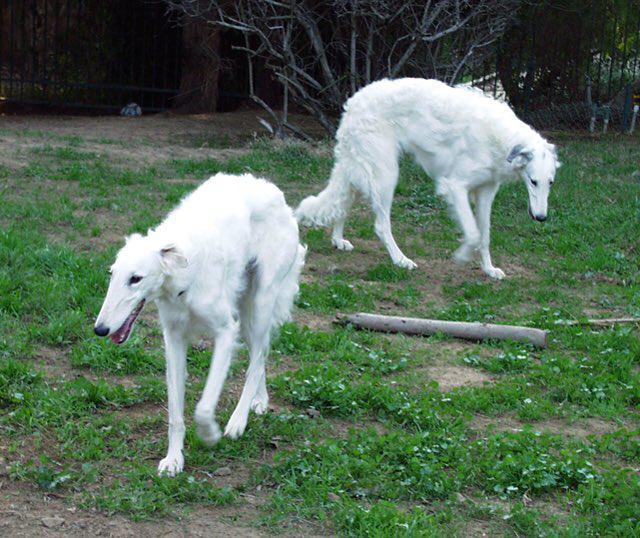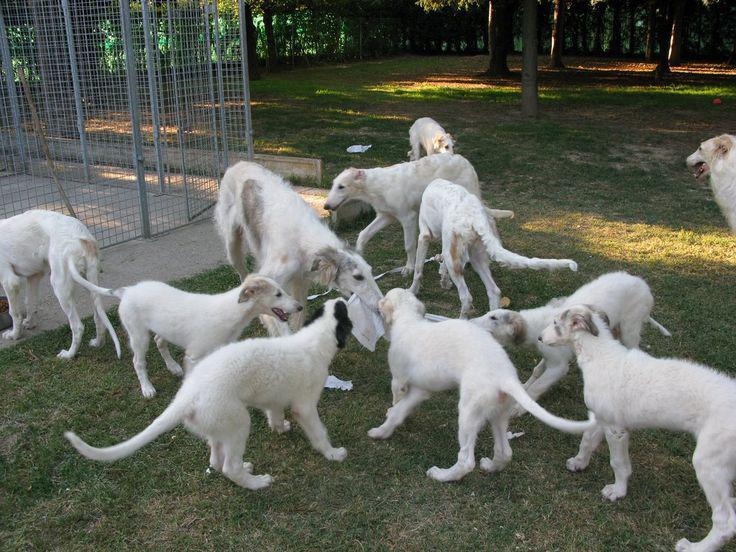The first image is the image on the left, the second image is the image on the right. Examine the images to the left and right. Is the description "The lefthand image contains one gray-and-white hound standing with its body turned leftward and face to the camera." accurate? Answer yes or no. No. The first image is the image on the left, the second image is the image on the right. Assess this claim about the two images: "There are more dogs outside in the image on the right.". Correct or not? Answer yes or no. Yes. 